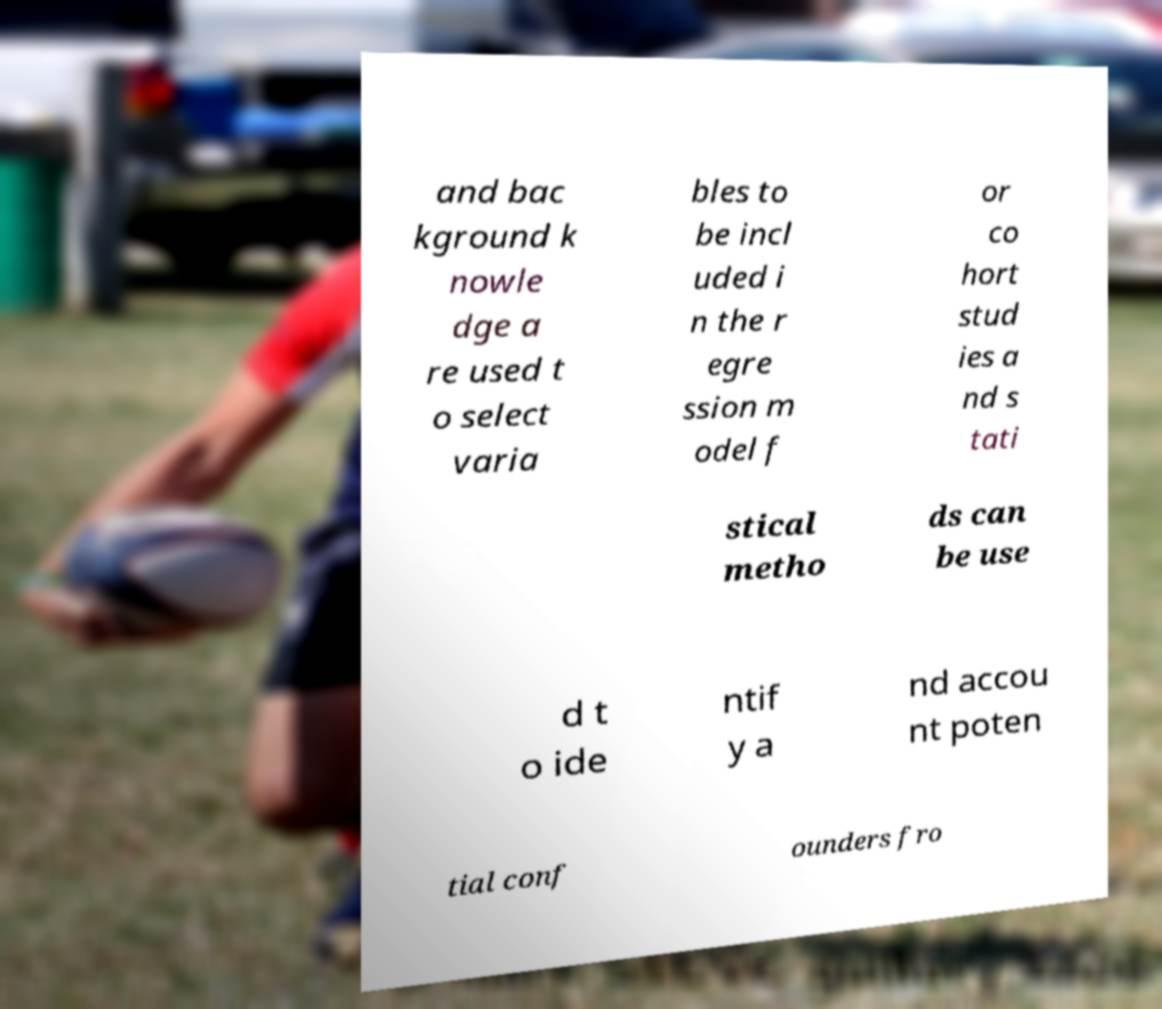There's text embedded in this image that I need extracted. Can you transcribe it verbatim? and bac kground k nowle dge a re used t o select varia bles to be incl uded i n the r egre ssion m odel f or co hort stud ies a nd s tati stical metho ds can be use d t o ide ntif y a nd accou nt poten tial conf ounders fro 